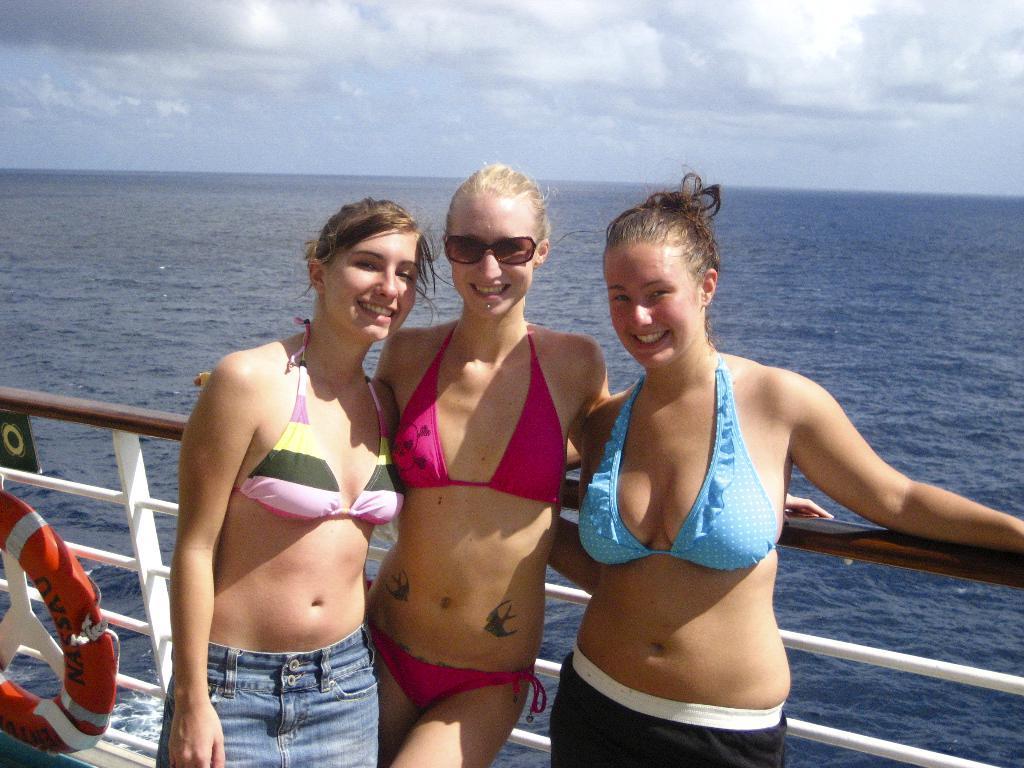How would you summarize this image in a sentence or two? In this picture, we see three women are standing. Three of them are smiling and they might be posing for the photo. Behind them, we see the railing. On the left side, we see an orange color tube. They might be standing in the ship. In the background, we see water and this water might be in the sea. At the top, we see the clouds and the sky. 